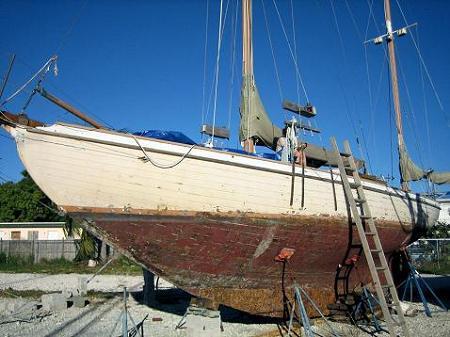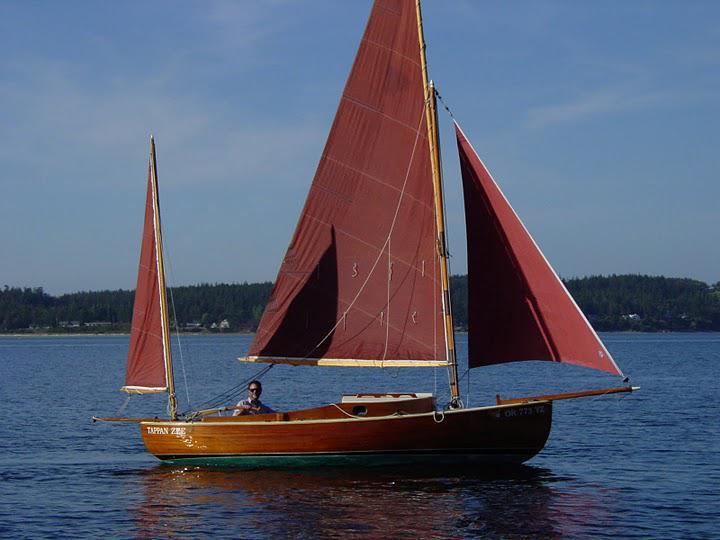The first image is the image on the left, the second image is the image on the right. Examine the images to the left and right. Is the description "In one of the images the boat is blue." accurate? Answer yes or no. No. 